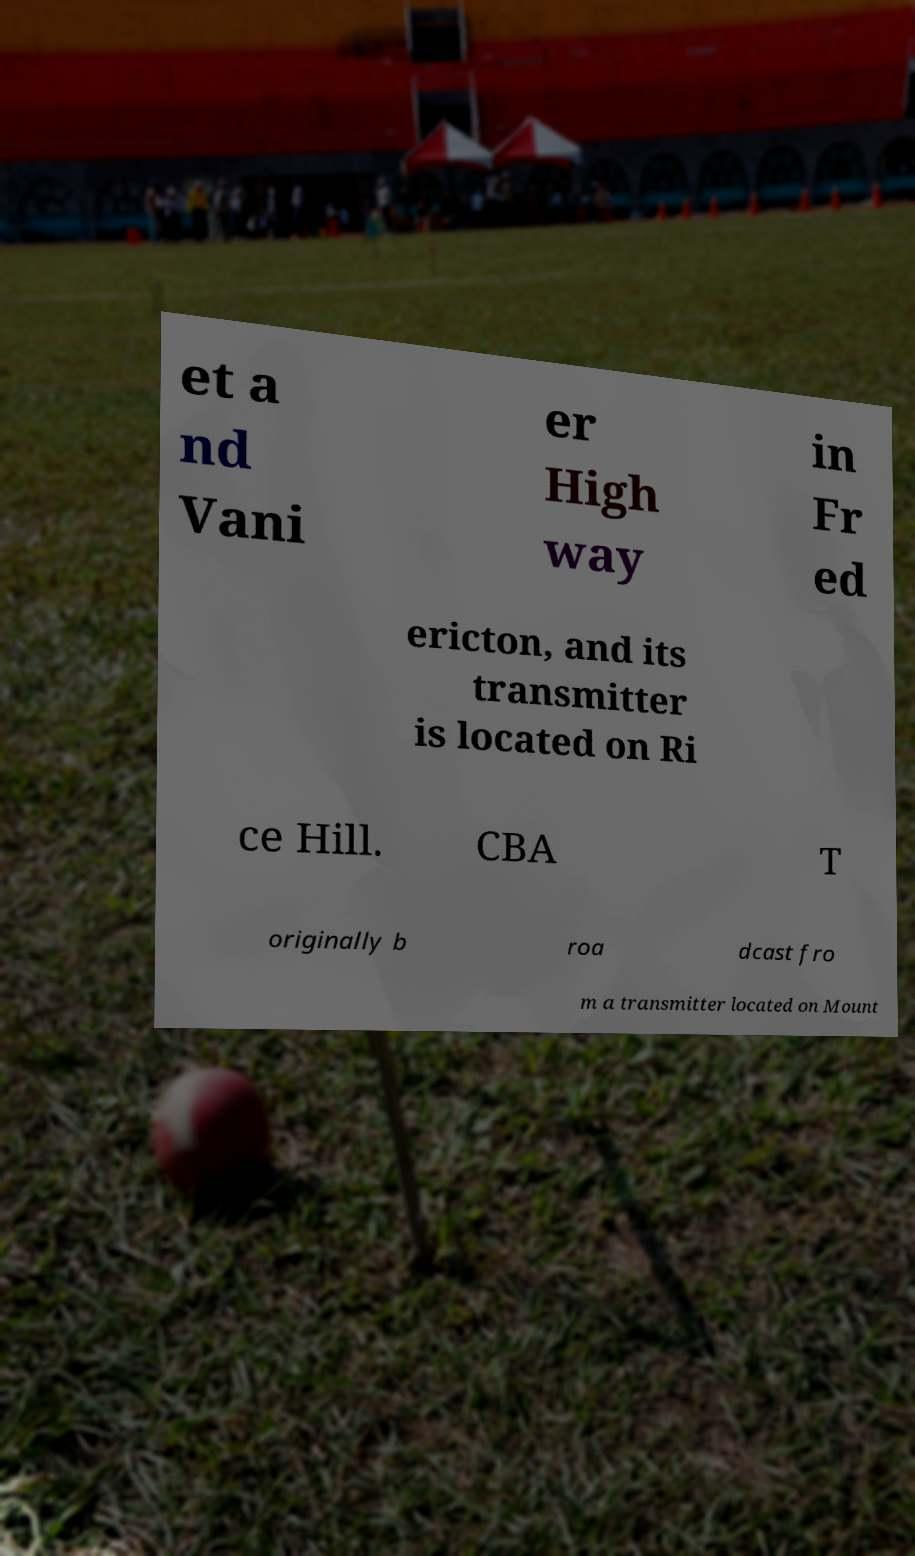Can you accurately transcribe the text from the provided image for me? et a nd Vani er High way in Fr ed ericton, and its transmitter is located on Ri ce Hill. CBA T originally b roa dcast fro m a transmitter located on Mount 